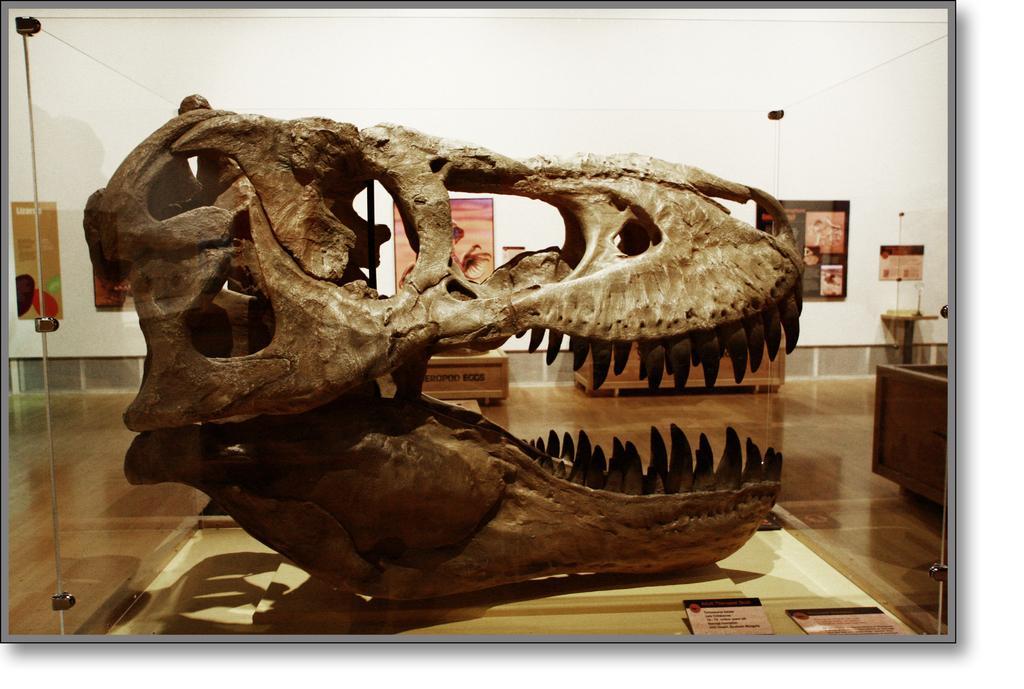Can you describe this image briefly? In this image I can see the dinosaur skull in the glass box, background I can see few frames attached to the wall and the wall is in white color. 